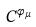<formula> <loc_0><loc_0><loc_500><loc_500>C ^ { \varphi _ { \mu } }</formula> 